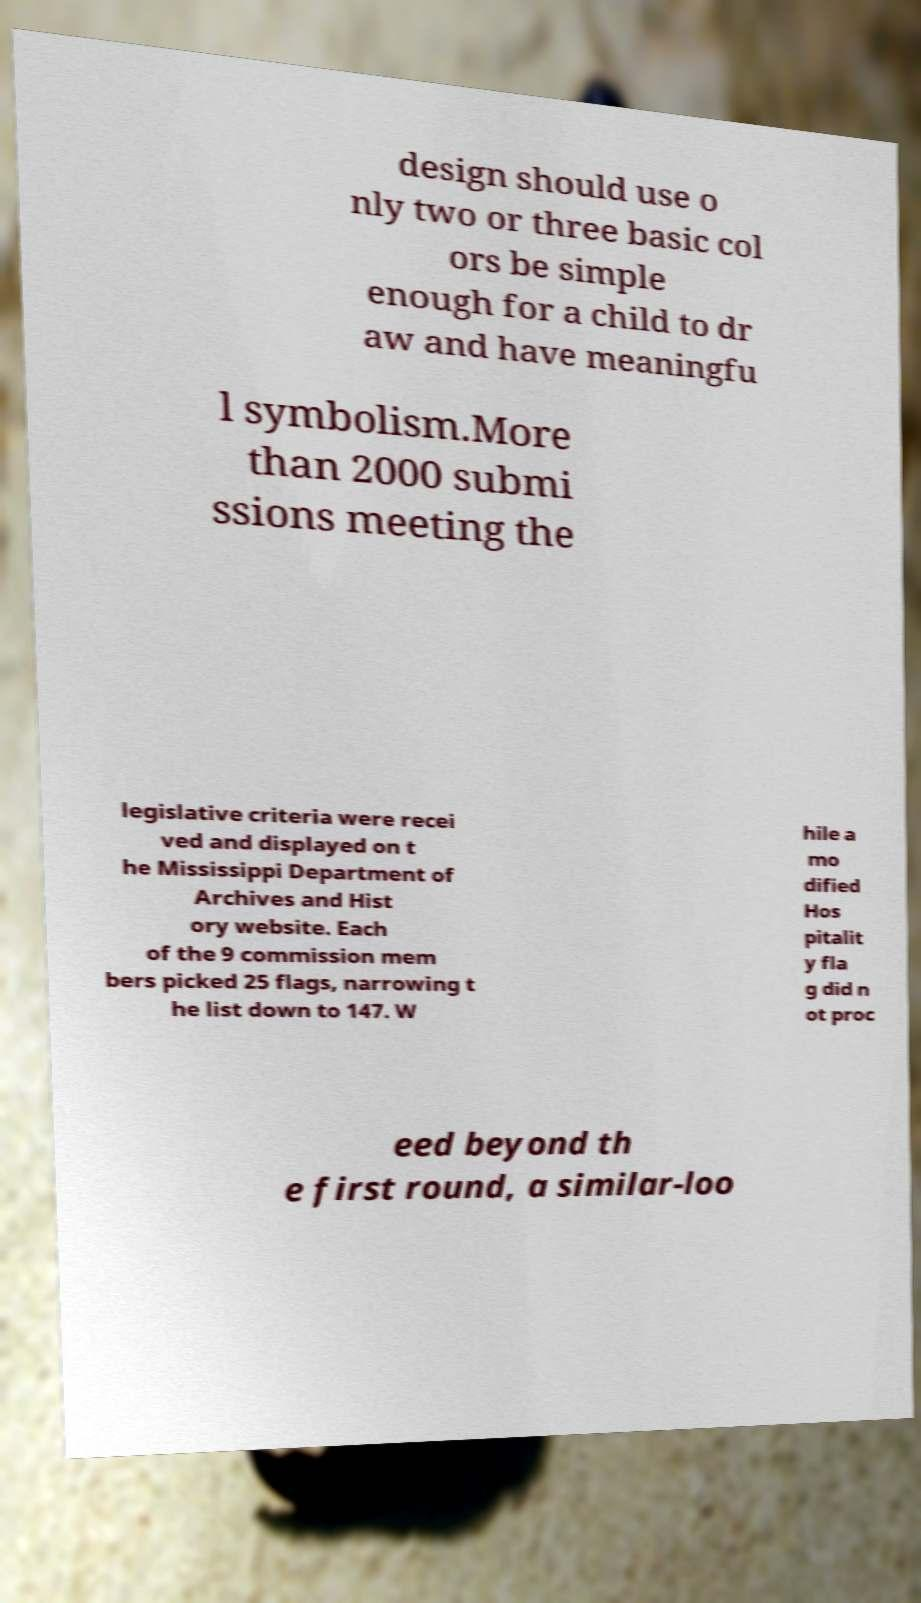Please read and relay the text visible in this image. What does it say? design should use o nly two or three basic col ors be simple enough for a child to dr aw and have meaningfu l symbolism.More than 2000 submi ssions meeting the legislative criteria were recei ved and displayed on t he Mississippi Department of Archives and Hist ory website. Each of the 9 commission mem bers picked 25 flags, narrowing t he list down to 147. W hile a mo dified Hos pitalit y fla g did n ot proc eed beyond th e first round, a similar-loo 